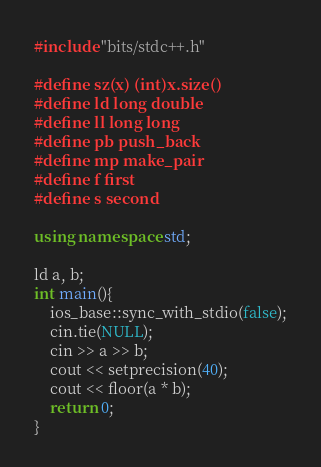Convert code to text. <code><loc_0><loc_0><loc_500><loc_500><_C++_>#include "bits/stdc++.h"

#define sz(x) (int)x.size()
#define ld long double
#define ll long long
#define pb push_back
#define mp make_pair
#define f first
#define s second

using namespace std;

ld a, b;
int main(){
    ios_base::sync_with_stdio(false);
    cin.tie(NULL);
    cin >> a >> b;
    cout << setprecision(40);
    cout << floor(a * b);
    return 0;
}</code> 